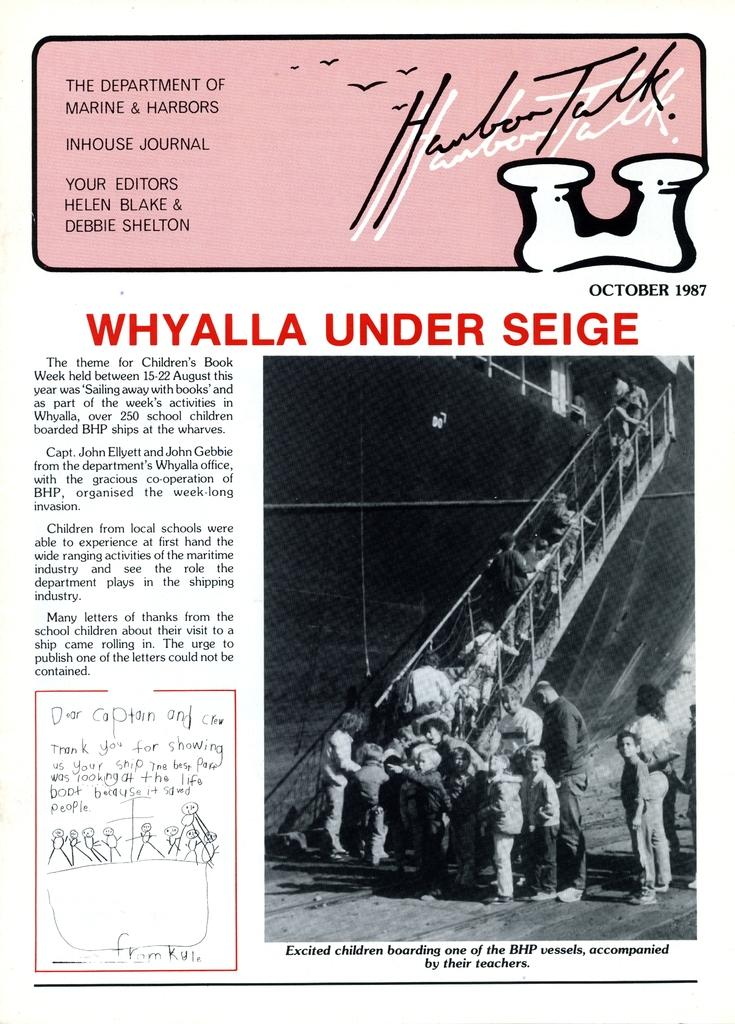What is featured in the image? There is a poster in the image. What can be seen on the right side of the poster? There is a black and white image on the right side of the poster. Where are people standing in the image? People are standing on the stairs and on the floor. What type of animals can be seen at the zoo in the image? There is no zoo present in the image, so it is not possible to determine what, if any, animals might be seen. 